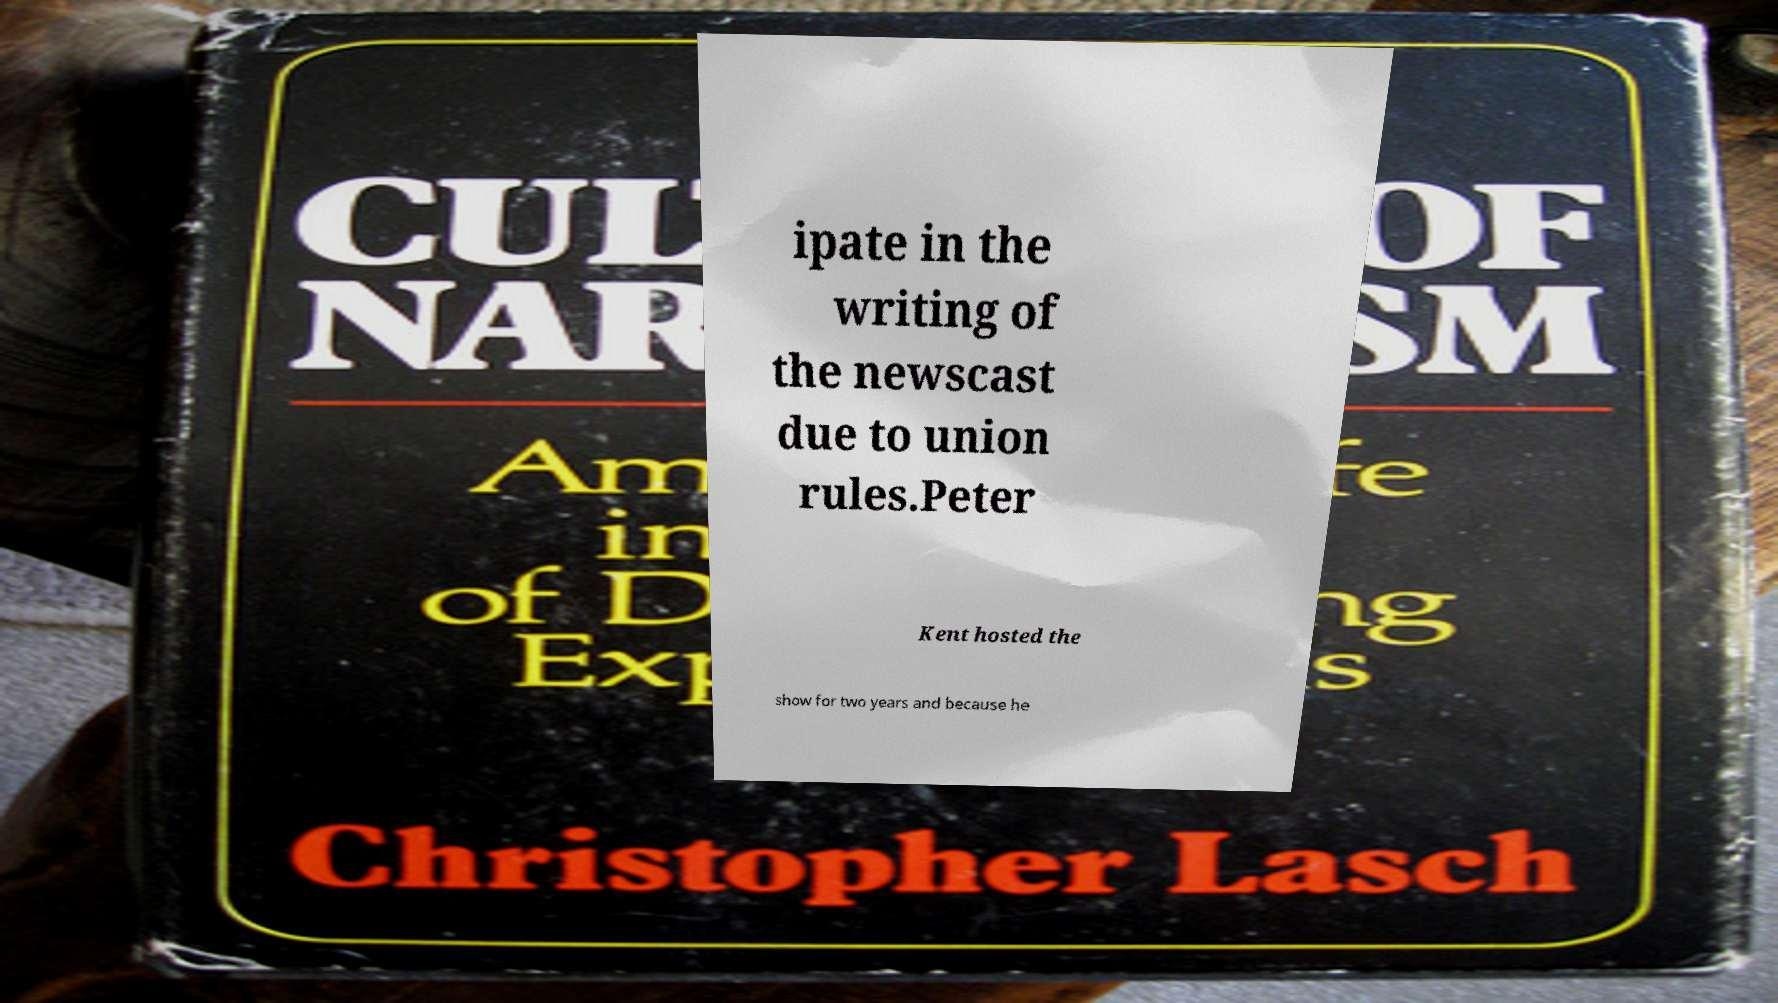Can you read and provide the text displayed in the image?This photo seems to have some interesting text. Can you extract and type it out for me? ipate in the writing of the newscast due to union rules.Peter Kent hosted the show for two years and because he 